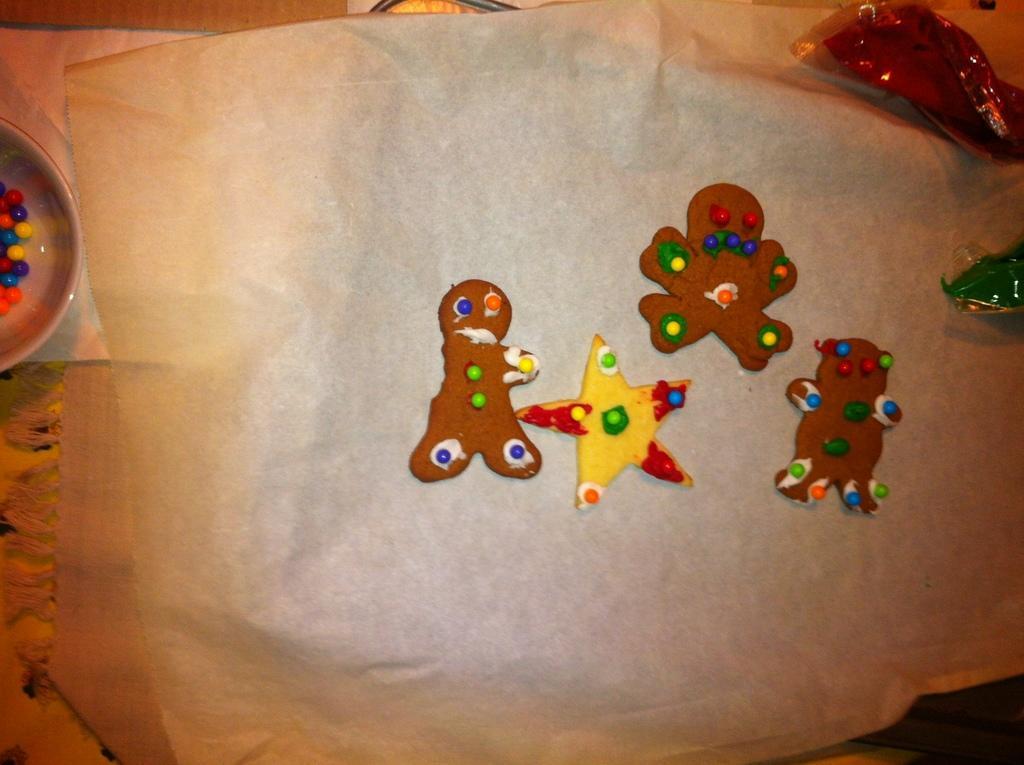Can you describe this image briefly? In this picture I can see painting on the cloth and I can see a bowl with colored balls on the side and a napkin. 